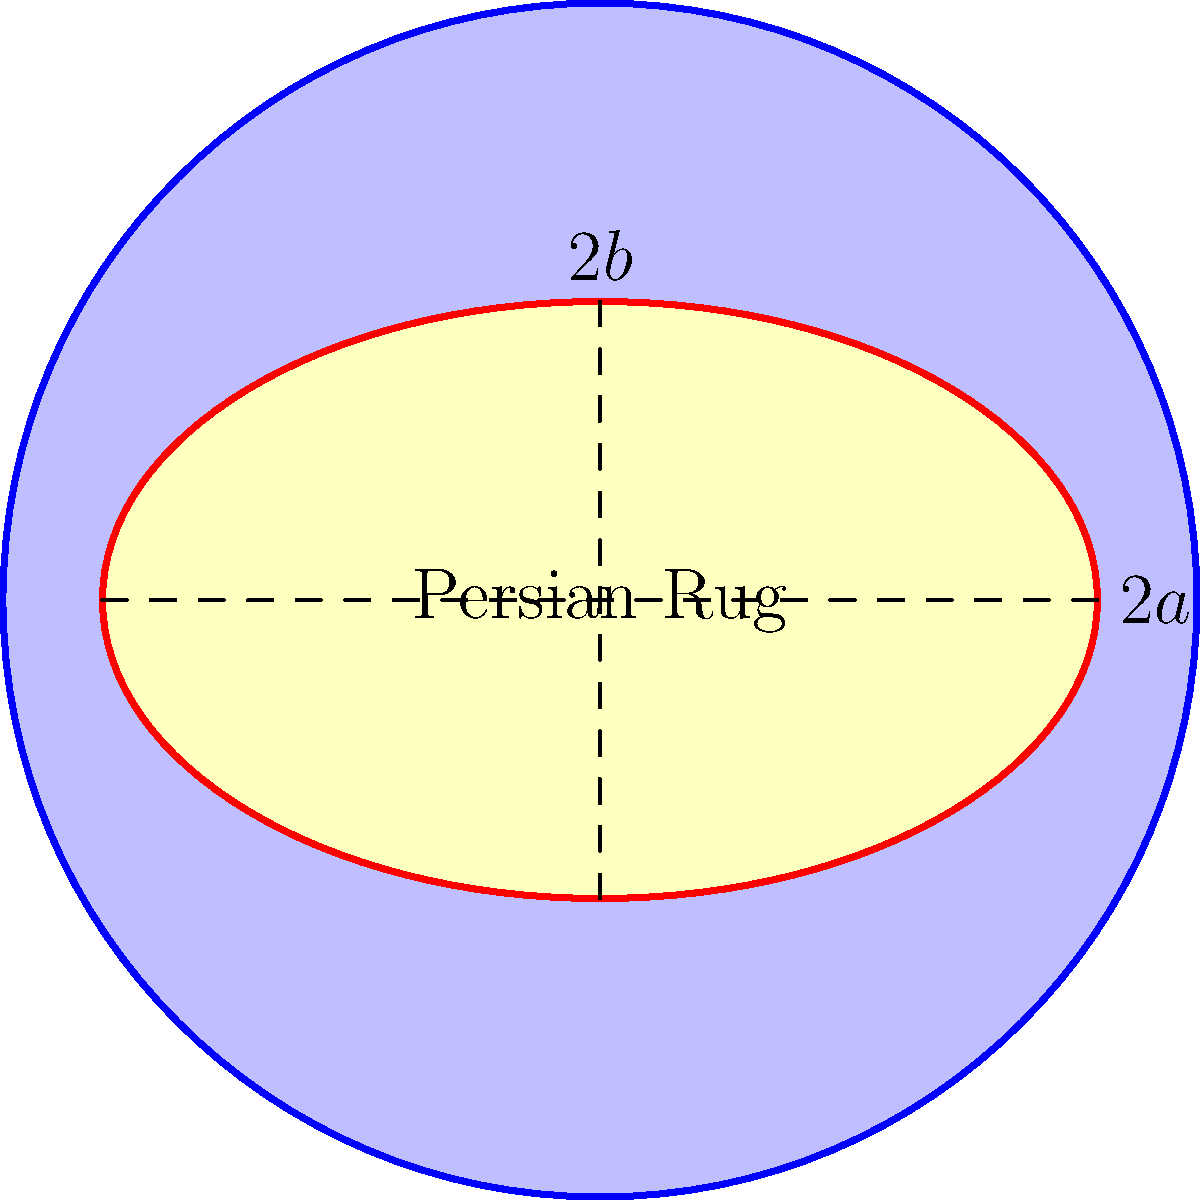You've acquired an exquisite elliptical Persian rug for your study. The rug measures 5 meters along its major axis and 3 meters along its minor axis. Given that the surface area of an ellipse is calculated using the formula $A = \pi ab$, where $a$ and $b$ are half the lengths of the major and minor axes respectively, what is the surface area of your new acquisition in square meters? Let's approach this step-by-step:

1) First, we need to identify the values of $a$ and $b$:
   - The major axis is 5 meters, so $a = 5/2 = 2.5$ meters
   - The minor axis is 3 meters, so $b = 3/2 = 1.5$ meters

2) Now we have the formula $A = \pi ab$, where:
   - $A$ is the area
   - $\pi$ is approximately 3.14159
   - $a = 2.5$
   - $b = 1.5$

3) Let's substitute these values into the formula:
   $A = \pi \cdot 2.5 \cdot 1.5$

4) Now we can calculate:
   $A = 3.14159 \cdot 2.5 \cdot 1.5 = 11.78 \text{ m}^2$ (rounded to two decimal places)

Therefore, the surface area of your new Persian rug is approximately 11.78 square meters.
Answer: $11.78 \text{ m}^2$ 